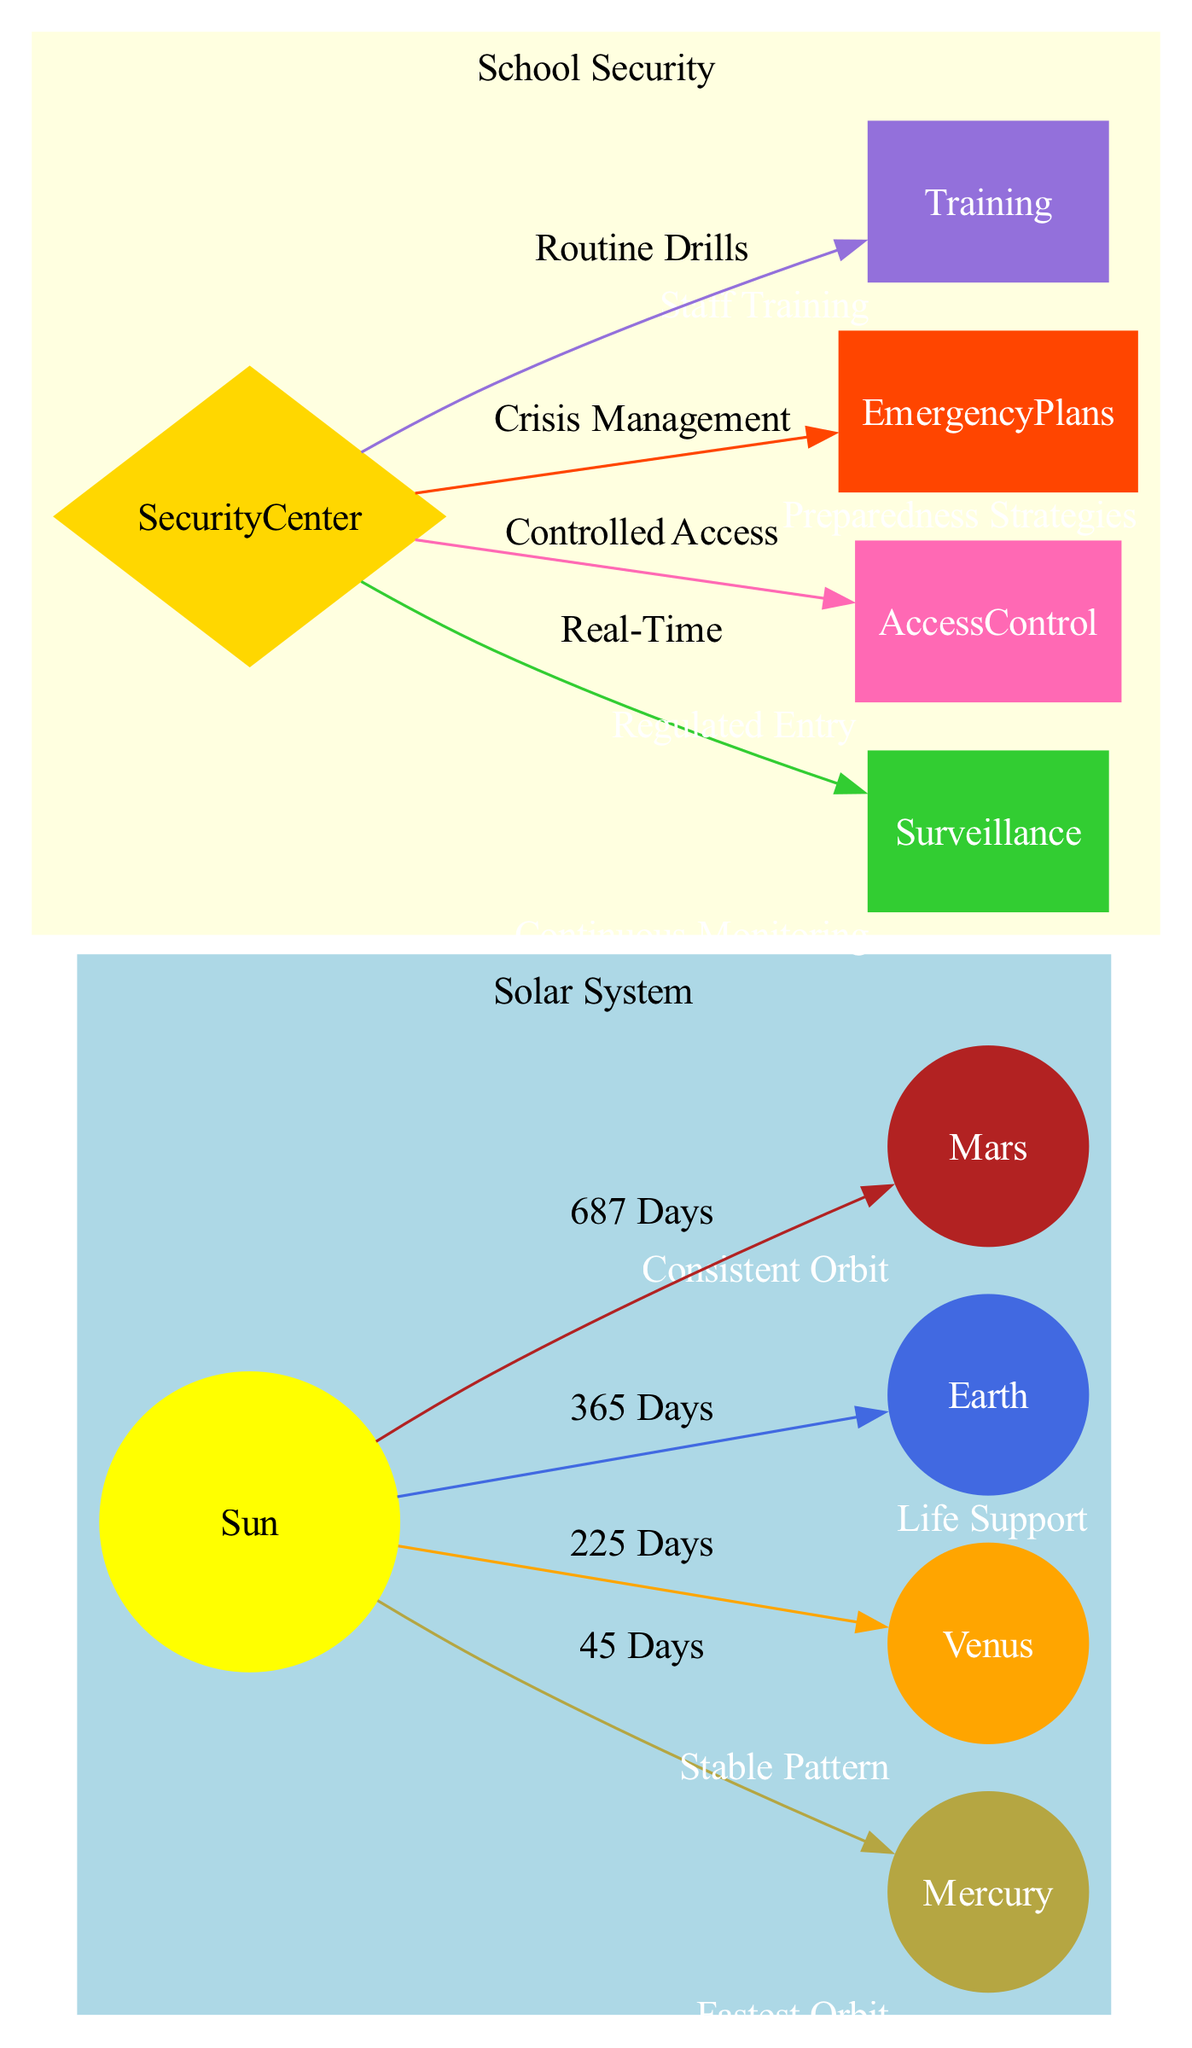What is the central node in the diagram? The central node is labeled "Sun," which is indicated as the center of the solar system. This node is the source around which all other planets orbit.
Answer: Sun How many planets are represented in the diagram? The diagram includes four planets: Mercury, Venus, Earth, and Mars. Each planet is visually distinct and represents a unique orbit around the Sun.
Answer: 4 Which planet has the longest orbital period? The planet Mars has the longest orbital period listed in the diagram, which is 687 days. This is longer in comparison to the other planets shown.
Answer: Mars What is the primary function of the Security Center? The Security Center serves as the central command for the school security protocols depicted in the diagram. It coordinates various security operations.
Answer: Central Command What connects the Security Center to Surveillance? The Security Center is connected to the Surveillance node with the label "Real-Time," indicating that the connection facilitates continuous monitoring.
Answer: Real-Time How many edges lead from the Sun? There are four edges leading from the Sun, connecting it to Mercury, Venus, Earth, and Mars. Each edge represents the orbital relationship between the Sun and the respective planets.
Answer: 4 What type of monitoring is represented in the diagram? The diagram includes the type of monitoring categorized as "Continuous Monitoring," which is shown under the Surveillance node connected to the Security Center.
Answer: Continuous Monitoring What is the description associated with the Earth node? The Earth node is described as "Life Support," indicating its critical role in sustaining life within the solar system.
Answer: Life Support Which protocol is associated with emergency preparedness? The protocol linked to emergency preparedness is labeled "Preparedness Strategies," connected from the Security Center to the Emergency Plans node.
Answer: Preparedness Strategies 